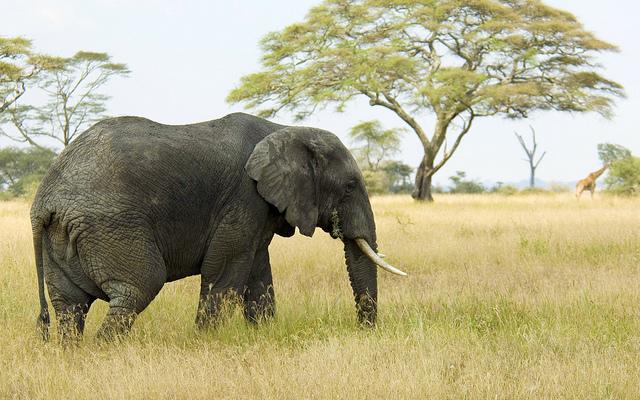Does this area receive consistent rainfall?
Quick response, please. No. What is in the distance?
Answer briefly. Giraffe. Which other animal is their other than elephant?
Give a very brief answer. Giraffe. 